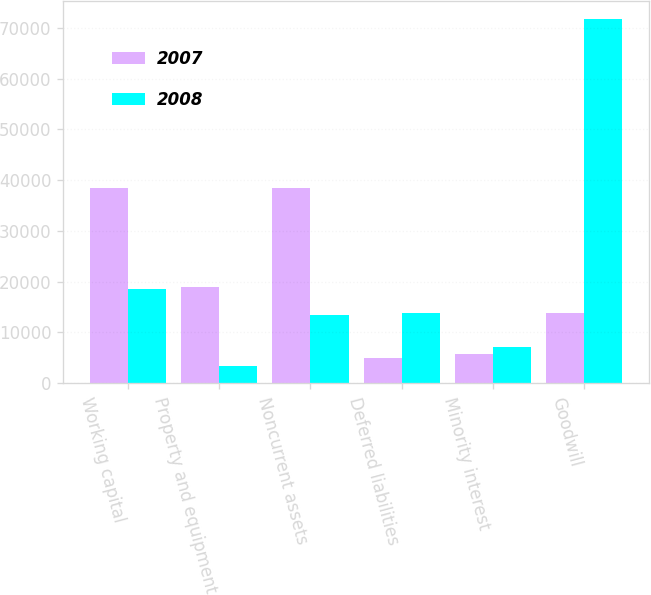Convert chart. <chart><loc_0><loc_0><loc_500><loc_500><stacked_bar_chart><ecel><fcel>Working capital<fcel>Property and equipment<fcel>Noncurrent assets<fcel>Deferred liabilities<fcel>Minority interest<fcel>Goodwill<nl><fcel>2007<fcel>38525<fcel>18878<fcel>38386<fcel>5046<fcel>5823<fcel>13791<nl><fcel>2008<fcel>18523<fcel>3414<fcel>13447<fcel>13791<fcel>7104<fcel>71700<nl></chart> 